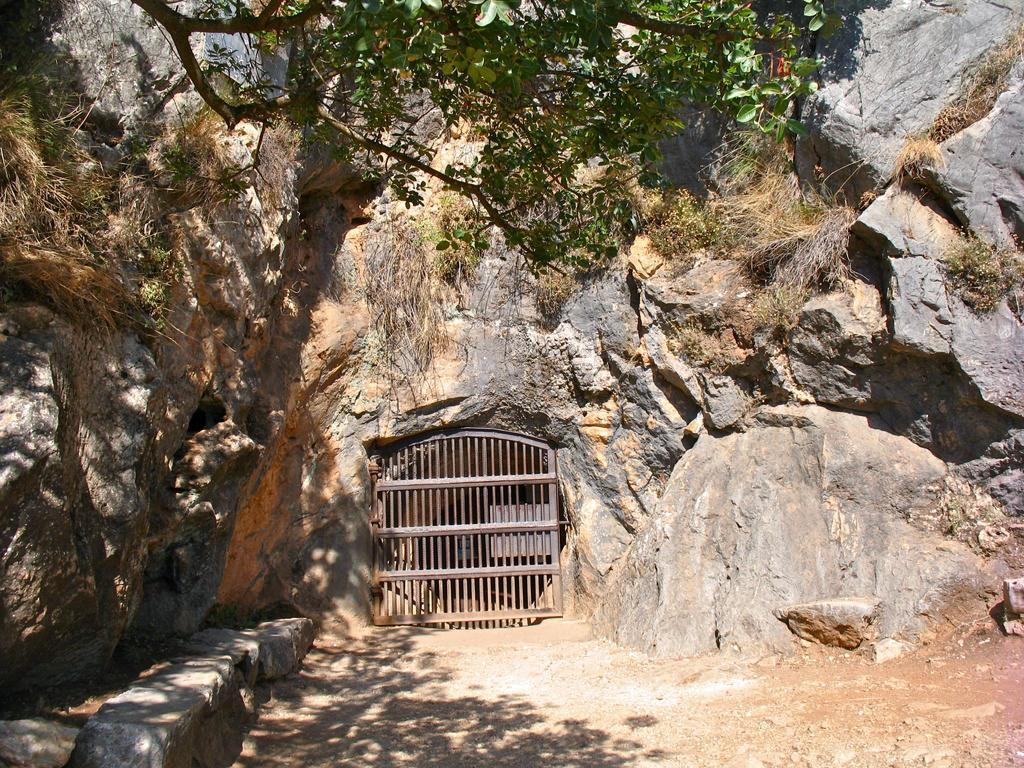What type of natural objects can be seen in the image? There are rocks in the image. Can you describe a specific rock in the image? There is a rock with a gate in the image. What type of vegetation is visible at the top of the image? There are branches with leaves at the top of the image. Are there any plants growing on the rocks in the image? Yes, there are small plants on the rocks in the image. Can you hear the sound of a carriage passing by in the image? There is no carriage present in the image, so it is not possible to hear its sound. 